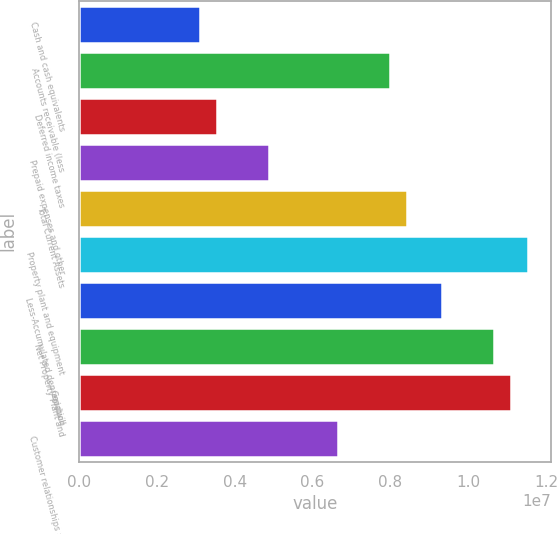Convert chart to OTSL. <chart><loc_0><loc_0><loc_500><loc_500><bar_chart><fcel>Cash and cash equivalents<fcel>Accounts receivable (less<fcel>Deferred income taxes<fcel>Prepaid expenses and other<fcel>Total Current Assets<fcel>Property plant and equipment<fcel>Less-Accumulated depreciation<fcel>Net Property Plant and<fcel>Goodwill<fcel>Customer relationships and<nl><fcel>3.11006e+06<fcel>7.99526e+06<fcel>3.55417e+06<fcel>4.8865e+06<fcel>8.43937e+06<fcel>1.15481e+07<fcel>9.32758e+06<fcel>1.06599e+07<fcel>1.1104e+07<fcel>6.66293e+06<nl></chart> 